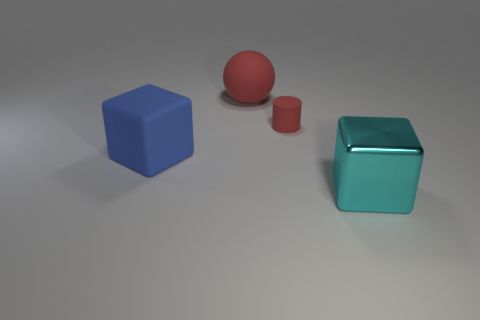There is another matte object that is the same color as the small object; what is its size?
Provide a succinct answer. Large. Is the color of the tiny matte thing the same as the rubber sphere?
Your answer should be compact. Yes. What is the color of the other big thing that is the same shape as the large blue object?
Offer a very short reply. Cyan. Is there anything else of the same color as the tiny matte cylinder?
Your answer should be very brief. Yes. What number of other large objects have the same material as the blue thing?
Offer a terse response. 1. How many large objects are to the right of the block left of the thing behind the small object?
Offer a very short reply. 2. Does the large shiny object have the same shape as the large red thing?
Ensure brevity in your answer.  No. Are there any other blue things that have the same shape as the big blue object?
Give a very brief answer. No. The cyan shiny object that is the same size as the blue thing is what shape?
Offer a terse response. Cube. What is the big block to the right of the big rubber object behind the big cube that is behind the cyan object made of?
Give a very brief answer. Metal. 